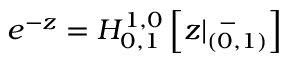Convert formula to latex. <formula><loc_0><loc_0><loc_500><loc_500>e ^ { - z } = H _ { 0 , 1 } ^ { 1 , 0 } \left [ z | _ { ( 0 , 1 ) } ^ { \, - } \right ]</formula> 